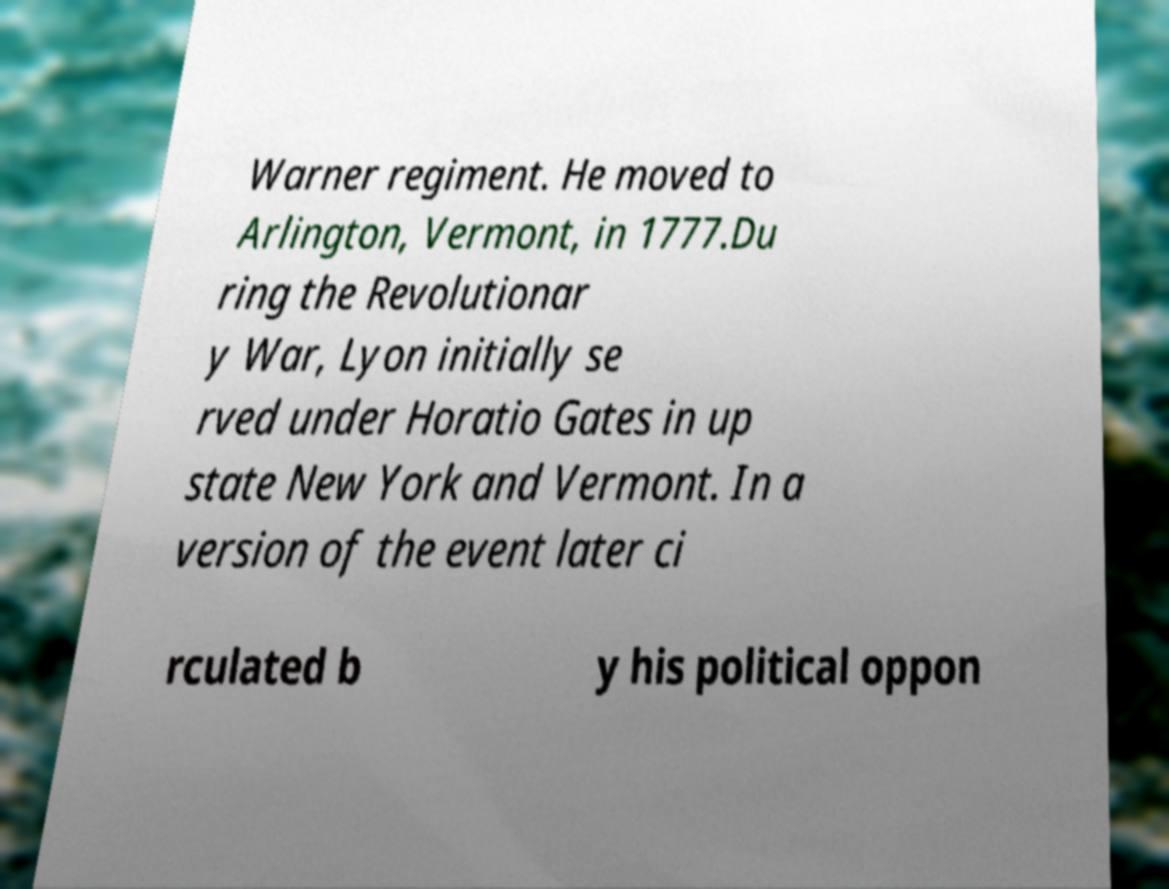Can you accurately transcribe the text from the provided image for me? Warner regiment. He moved to Arlington, Vermont, in 1777.Du ring the Revolutionar y War, Lyon initially se rved under Horatio Gates in up state New York and Vermont. In a version of the event later ci rculated b y his political oppon 